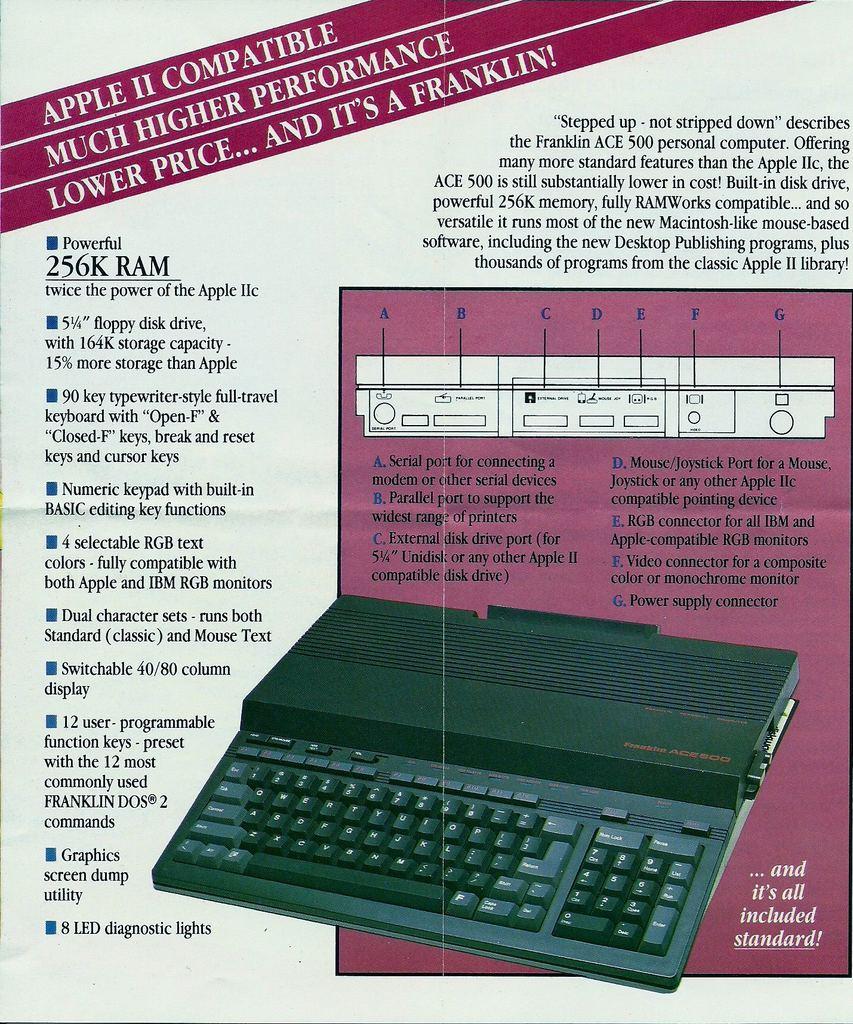What brand is it?
Keep it short and to the point. Apple. 